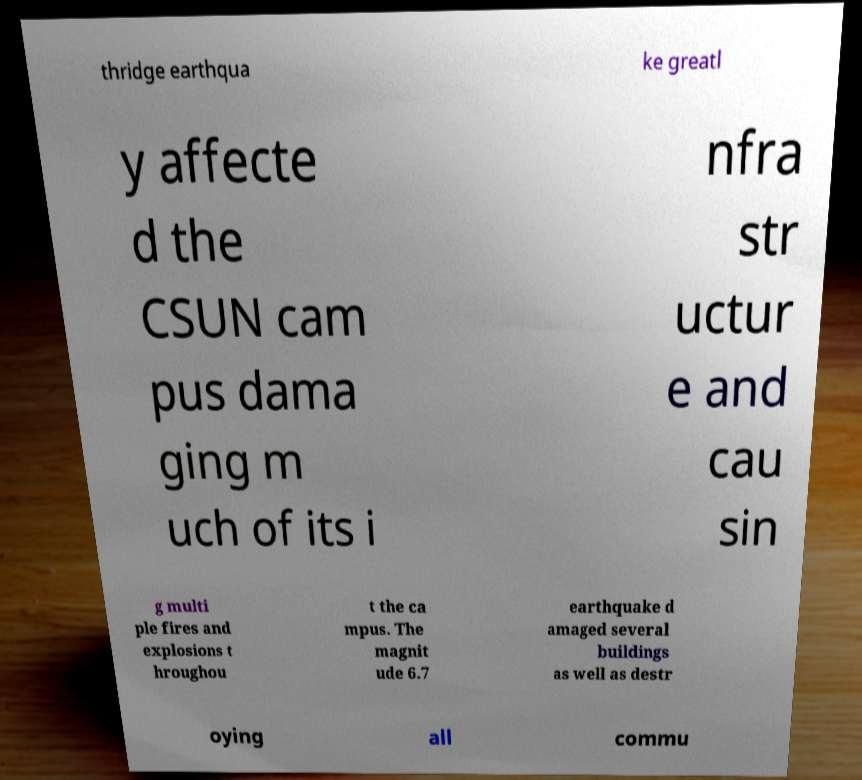For documentation purposes, I need the text within this image transcribed. Could you provide that? thridge earthqua ke greatl y affecte d the CSUN cam pus dama ging m uch of its i nfra str uctur e and cau sin g multi ple fires and explosions t hroughou t the ca mpus. The magnit ude 6.7 earthquake d amaged several buildings as well as destr oying all commu 